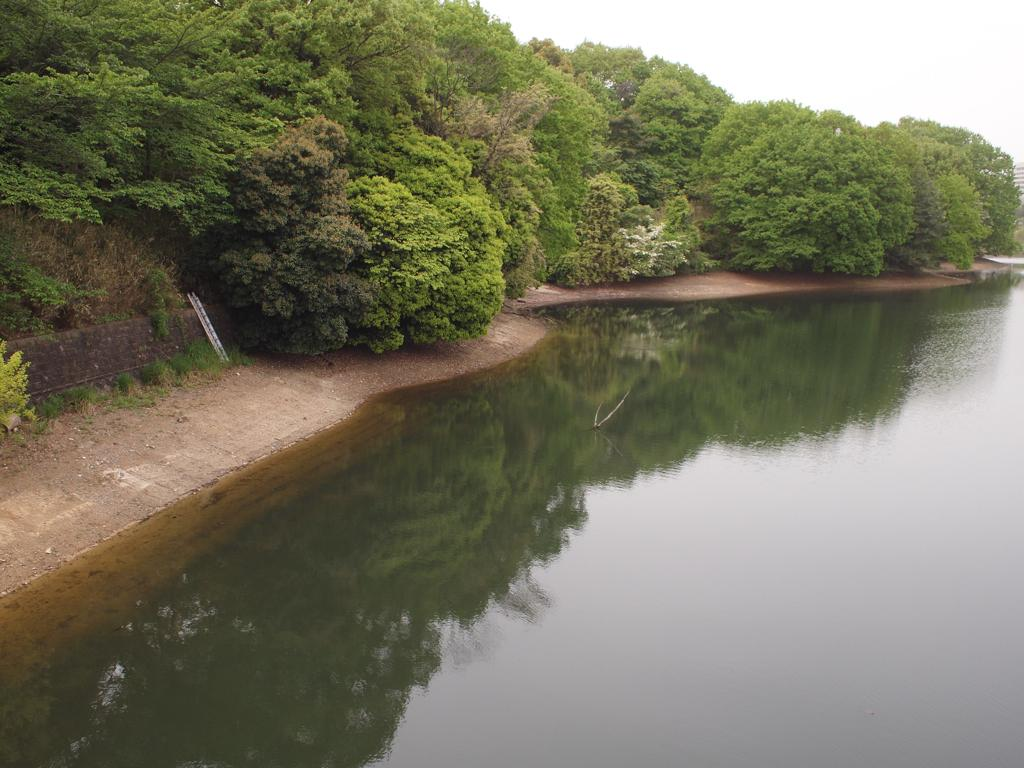What is at the bottom of the image? There is a surface of water at the bottom of the image. What can be seen in the background of the image? There are trees in the background of the image. What is visible at the top of the image? The sky is visible at the top of the image. What type of toys can be seen in the afternoon in the image? There are no toys or indication of time of day in the image; it features a surface of water, trees, and the sky. 